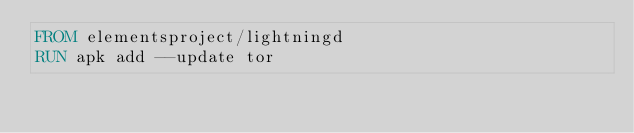Convert code to text. <code><loc_0><loc_0><loc_500><loc_500><_Dockerfile_>FROM elementsproject/lightningd
RUN apk add --update tor</code> 